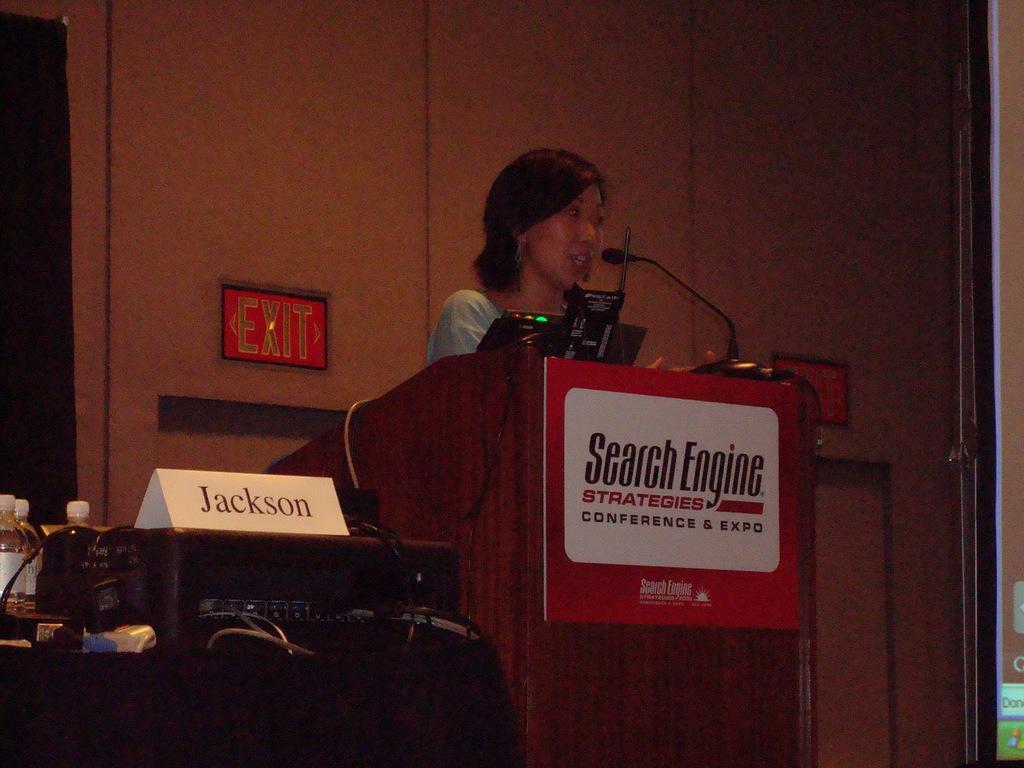Please provide a concise description of this image. In this image there is a woman standing near the podium and speaking in the mic. There is a board attached to the podium. On the right side there is a screen. On the left side there is a table on which there are bottles and an amplifier. On the amplifier there is a name board. In the background there is a exit board symbol attached to the wall. 